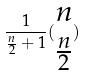<formula> <loc_0><loc_0><loc_500><loc_500>\frac { 1 } { \frac { n } { 2 } + 1 } ( \begin{matrix} n \\ \frac { n } { 2 } \end{matrix} )</formula> 